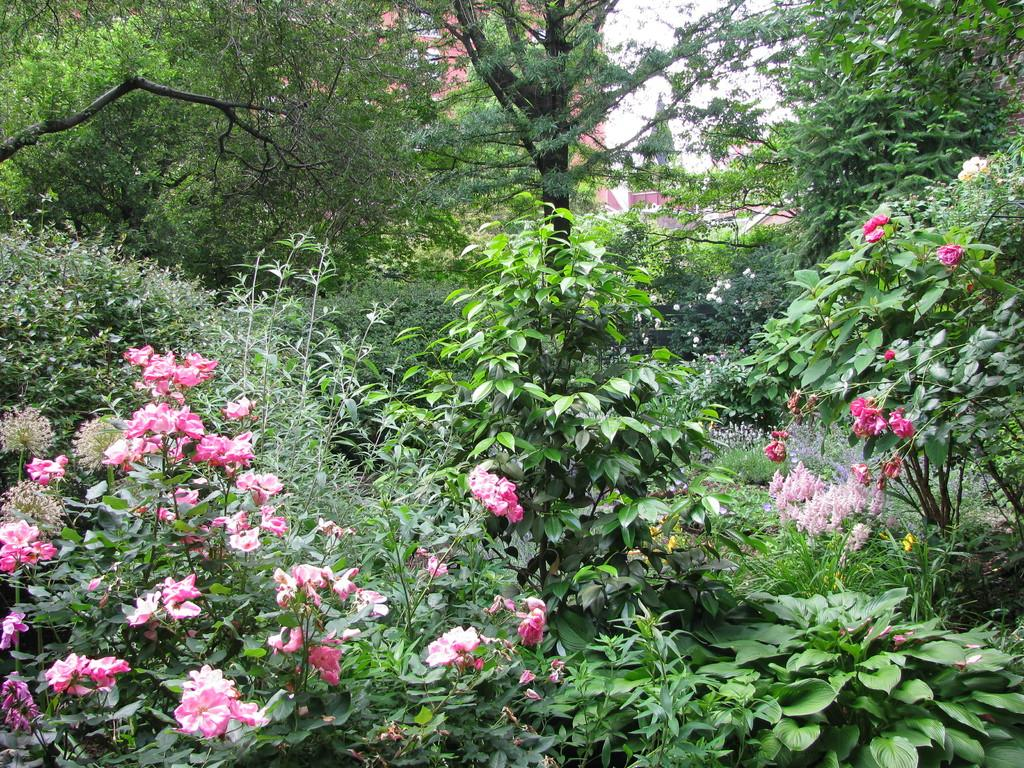What type of plants can be seen in the image? There are pink flower plants in the image. What other natural elements are present in the image? There are trees in the image. What can be seen in the background of the image? There are buildings in the background of the image. Can you see a stream flowing through the pink flower plants in the image? There is no stream present in the image; it features pink flower plants, trees, and buildings in the background. 